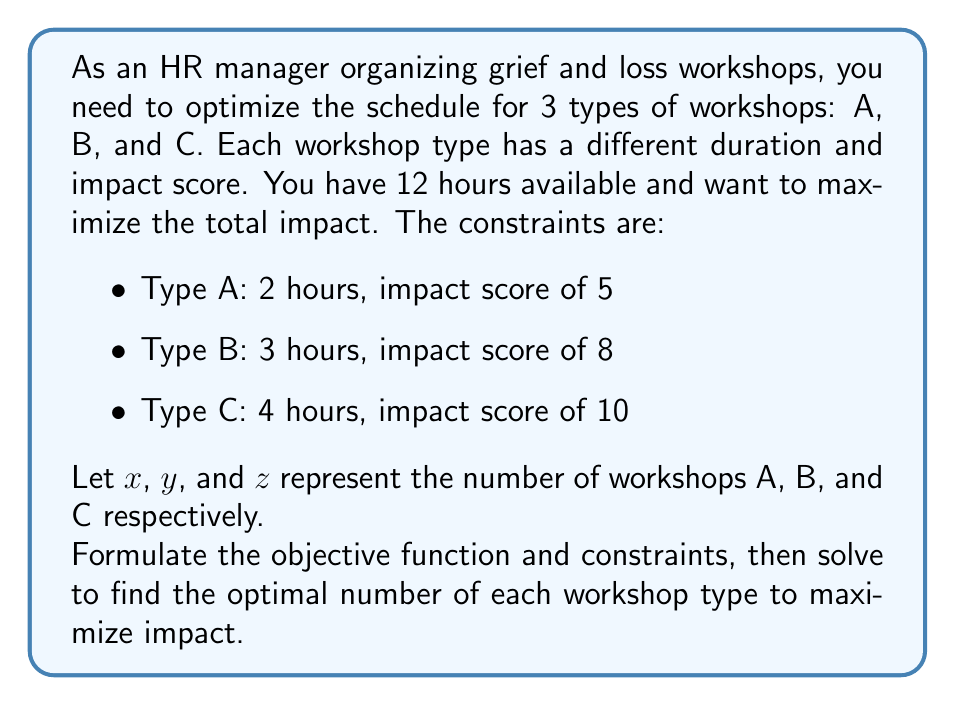Show me your answer to this math problem. 1) First, let's formulate the objective function to maximize impact:
   $$\text{Maximize } f(x,y,z) = 5x + 8y + 10z$$

2) Now, let's set up the constraints:
   Time constraint: $$2x + 3y + 4z \leq 12$$
   Non-negativity: $$x, y, z \geq 0$$
   Integer constraint: $$x, y, z \in \mathbb{Z}$$

3) This is an integer linear programming problem. We can solve it using the simplex method and then round down to the nearest integer solution.

4) The feasible integer solutions are:
   $(0,0,3)$, $(0,4,0)$, $(1,2,1)$, $(2,1,1)$, $(3,2,0)$, $(6,0,0)$

5) Evaluating the objective function for each:
   $f(0,0,3) = 30$
   $f(0,4,0) = 32$
   $f(1,2,1) = 31$
   $f(2,1,1) = 28$
   $f(3,2,0) = 31$
   $f(6,0,0) = 30$

6) The maximum impact is achieved with the solution $(0,4,0)$, which means conducting 4 Type B workshops.
Answer: 4 Type B workshops 